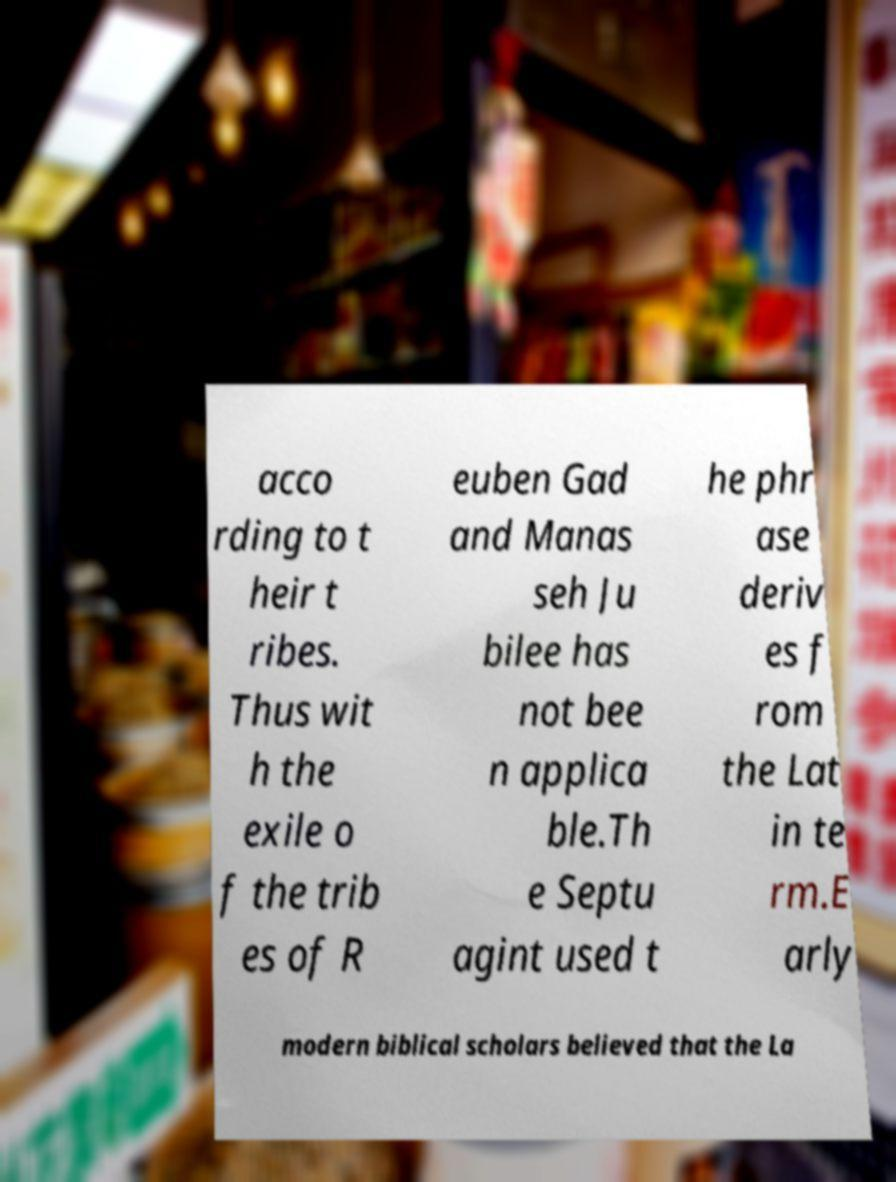Can you accurately transcribe the text from the provided image for me? acco rding to t heir t ribes. Thus wit h the exile o f the trib es of R euben Gad and Manas seh Ju bilee has not bee n applica ble.Th e Septu agint used t he phr ase deriv es f rom the Lat in te rm.E arly modern biblical scholars believed that the La 